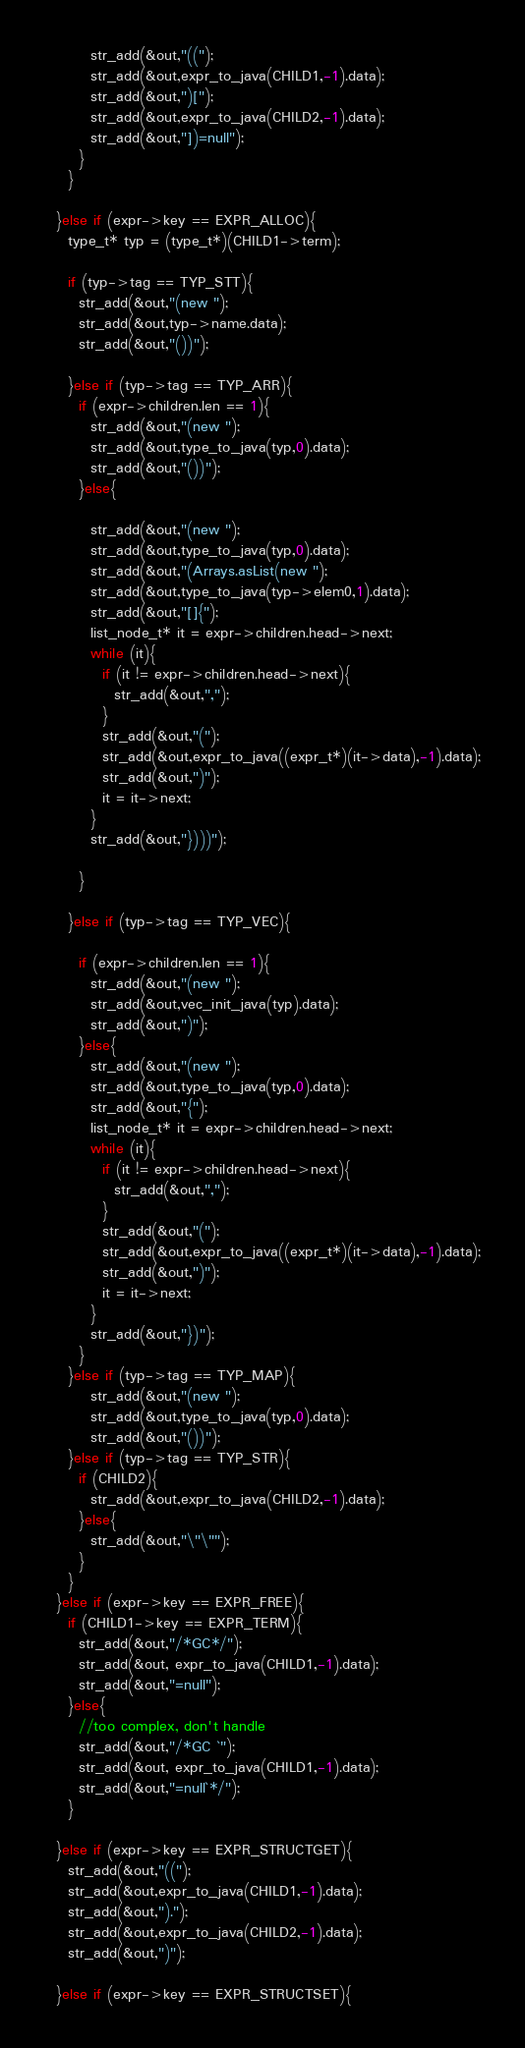<code> <loc_0><loc_0><loc_500><loc_500><_C_>        str_add(&out,"((");
        str_add(&out,expr_to_java(CHILD1,-1).data);
        str_add(&out,")[");
        str_add(&out,expr_to_java(CHILD2,-1).data);
        str_add(&out,"])=null");
      }
    }

  }else if (expr->key == EXPR_ALLOC){
    type_t* typ = (type_t*)(CHILD1->term);

    if (typ->tag == TYP_STT){
      str_add(&out,"(new ");
      str_add(&out,typ->name.data);
      str_add(&out,"())");

    }else if (typ->tag == TYP_ARR){
      if (expr->children.len == 1){
        str_add(&out,"(new ");
        str_add(&out,type_to_java(typ,0).data);
        str_add(&out,"())");
      }else{

        str_add(&out,"(new ");
        str_add(&out,type_to_java(typ,0).data);
        str_add(&out,"(Arrays.asList(new ");
        str_add(&out,type_to_java(typ->elem0,1).data);
        str_add(&out,"[]{");
        list_node_t* it = expr->children.head->next;
        while (it){
          if (it != expr->children.head->next){
            str_add(&out,",");
          }
          str_add(&out,"(");
          str_add(&out,expr_to_java((expr_t*)(it->data),-1).data);
          str_add(&out,")");
          it = it->next;
        }
        str_add(&out,"})))");
        
      }

    }else if (typ->tag == TYP_VEC){

      if (expr->children.len == 1){
        str_add(&out,"(new ");
        str_add(&out,vec_init_java(typ).data);
        str_add(&out,")");
      }else{
        str_add(&out,"(new ");
        str_add(&out,type_to_java(typ,0).data);
        str_add(&out,"{");
        list_node_t* it = expr->children.head->next;
        while (it){
          if (it != expr->children.head->next){
            str_add(&out,",");
          }
          str_add(&out,"(");
          str_add(&out,expr_to_java((expr_t*)(it->data),-1).data);
          str_add(&out,")");
          it = it->next;
        }
        str_add(&out,"})");        
      }
    }else if (typ->tag == TYP_MAP){
        str_add(&out,"(new ");
        str_add(&out,type_to_java(typ,0).data);
        str_add(&out,"())");
    }else if (typ->tag == TYP_STR){
      if (CHILD2){
        str_add(&out,expr_to_java(CHILD2,-1).data);
      }else{
        str_add(&out,"\"\"");
      }
    }
  }else if (expr->key == EXPR_FREE){
    if (CHILD1->key == EXPR_TERM){
      str_add(&out,"/*GC*/");
      str_add(&out, expr_to_java(CHILD1,-1).data);
      str_add(&out,"=null");
    }else{
      //too complex, don't handle
      str_add(&out,"/*GC `");
      str_add(&out, expr_to_java(CHILD1,-1).data);
      str_add(&out,"=null`*/");
    }

  }else if (expr->key == EXPR_STRUCTGET){
    str_add(&out,"((");
    str_add(&out,expr_to_java(CHILD1,-1).data);
    str_add(&out,").");
    str_add(&out,expr_to_java(CHILD2,-1).data);
    str_add(&out,")");

  }else if (expr->key == EXPR_STRUCTSET){</code> 